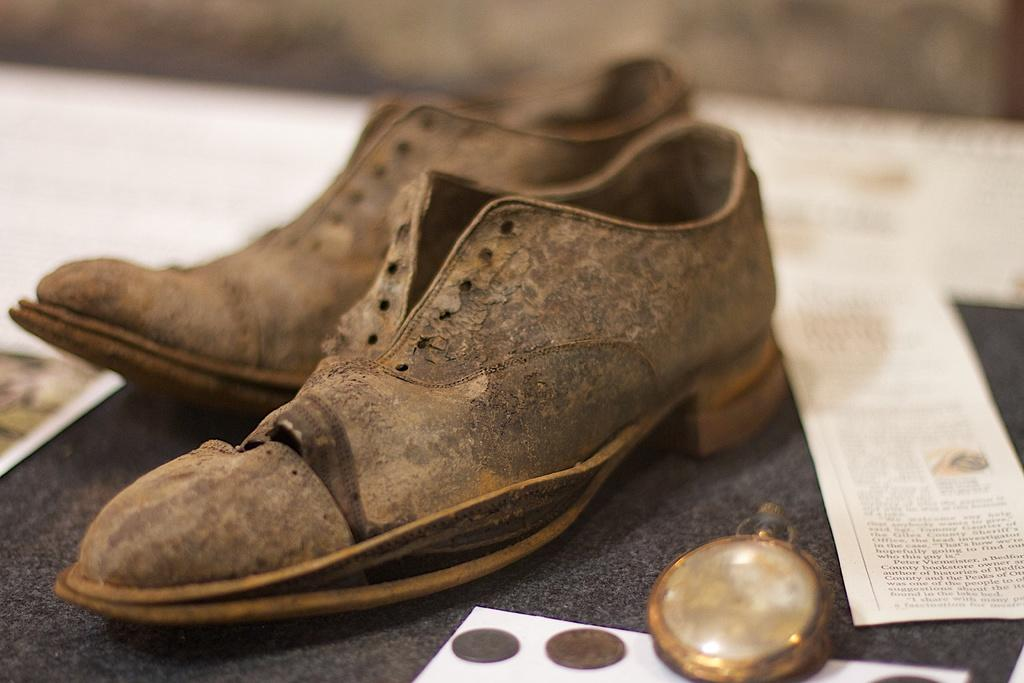What type of objects can be seen in the image? There are shoes, papers, and coins in the image. Can you describe any other objects present in the image? There are other unspecified objects in the image. Is there any quicksand visible in the image? No, there is no quicksand present in the image. Can you see a tent in the image? No, there is no tent present in the image. 